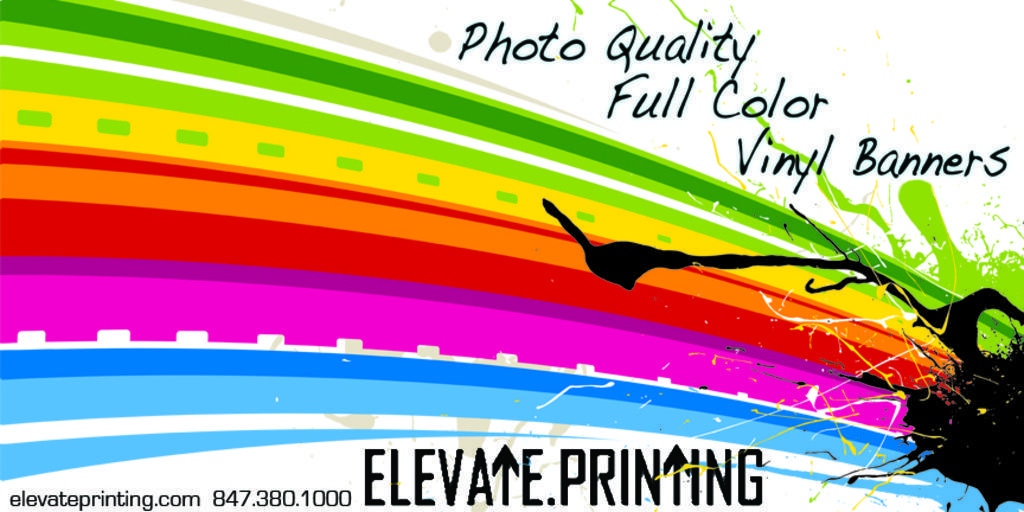Could you give a brief overview of what you see in this image? This image consists of a poster in which there are many colors along with the text. 